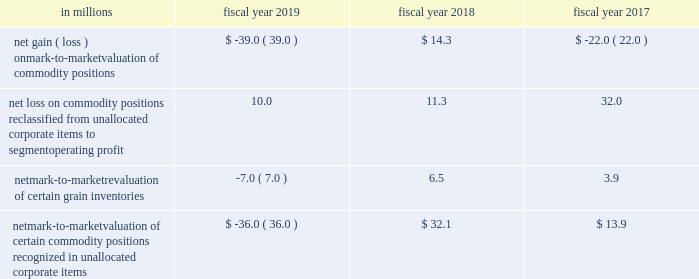Commodities purchased for use in our supply chain .
We manage our exposures through a combination of purchase orders , long-term contracts with suppliers , exchange-traded futures and options , and over-the-counter options and swaps .
We offset our exposures based on current and projected market conditions and generally seek to acquire the inputs at as close to our planned cost as possible .
We use derivatives to manage our exposure to changes in commodity prices .
We do not perform the assessments required to achieve hedge accounting for commodity derivative positions .
Accordingly , the changes in the values of these derivatives are recorded currently in cost of sales in our consolidated statements of earnings .
Although we do not meet the criteria for cash flow hedge accounting , we believe that these instruments are effective in achieving our objective of providing certainty in the future price of commodities purchased for use in our supply chain .
Accordingly , for purposes of measuring segment operating performance these gains and losses are reported in unallocated corporate items outside of segment operating results until such time that the exposure we are managing affects earnings .
At that time we reclassify the gain or loss from unallocated corporate items to segment operating profit , allowing our operating segments to realize the economic effects of the derivative without experiencing any resulting mark-to-market volatility , which remains in unallocated corporate items .
Unallocated corporate items for fiscal 2019 , 2018 and 2017 included: .
Net mark-to-market valuation of certain commodity positions recognized in unallocated corporate items $ ( 36.0 ) $ 32.1 $ 13.9 as of may 26 , 2019 , the net notional value of commodity derivatives was $ 312.5 million , of which $ 242.9 million related to agricultural inputs and $ 69.6 million related to energy inputs .
These contracts relate to inputs that generally will be utilized within the next 12 months .
Interest rate risk we are exposed to interest rate volatility with regard to future issuances of fixed-rate debt , and existing and future issuances of floating-rate debt .
Primary exposures include u.s .
Treasury rates , libor , euribor , and commercial paper rates in the united states and europe .
We use interest rate swaps , forward-starting interest rate swaps , and treasury locks to hedge our exposure to interest rate changes , to reduce the volatility of our financing costs , and to achieve a desired proportion of fixed rate versus floating-rate debt , based on current and projected market conditions .
Generally under these swaps , we agree with a counterparty to exchange the difference between fixed-rate and floating-rate interest amounts based on an agreed upon notional principal amount .
Floating interest rate exposures 2014 floating-to-fixed interest rate swaps are accounted for as cash flow hedges , as are all hedges of forecasted issuances of debt .
Effectiveness is assessed based on either the perfectly effective hypothetical derivative method or changes in the present value of interest payments on the underlying debt .
Effective gains and losses deferred to aoci are reclassified into earnings over the life of the associated debt .
Ineffective gains and losses are recorded as net interest .
The amount of hedge ineffectiveness was less than $ 1 million in fiscal 2019 , a $ 2.6 million loss in fiscal 2018 , and less than $ 1 million in fiscal 2017 .
Fixed interest rate exposures 2014 fixed-to-floating interest rate swaps are accounted for as fair value hedges with effectiveness assessed based on changes in the fair value of the underlying debt and derivatives , using .
What portion of the net notional value of commodity derivatives is related to energy inputs? 
Computations: (69.6 / 242.9)
Answer: 0.28654. 